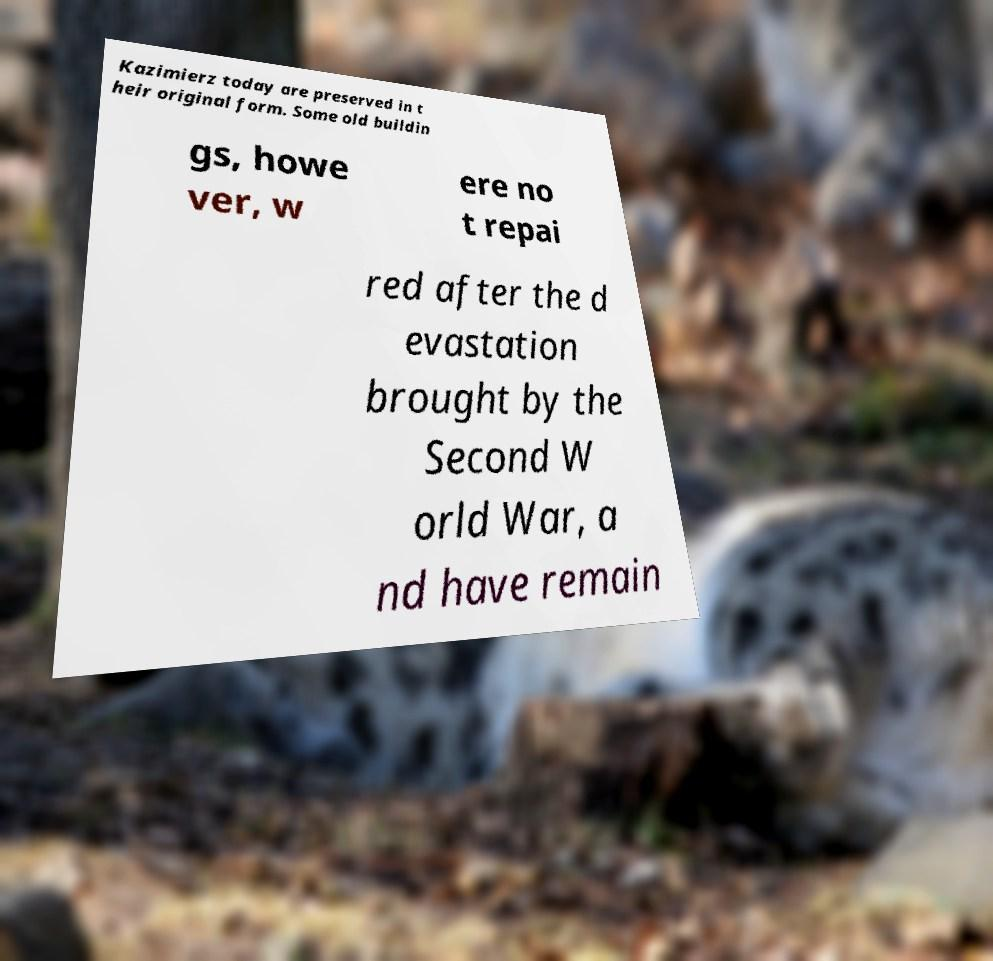There's text embedded in this image that I need extracted. Can you transcribe it verbatim? Kazimierz today are preserved in t heir original form. Some old buildin gs, howe ver, w ere no t repai red after the d evastation brought by the Second W orld War, a nd have remain 